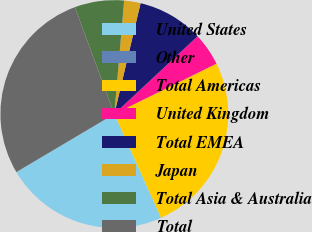Convert chart to OTSL. <chart><loc_0><loc_0><loc_500><loc_500><pie_chart><fcel>United States<fcel>Other<fcel>Total Americas<fcel>United Kingdom<fcel>Total EMEA<fcel>Japan<fcel>Total Asia & Australia<fcel>Total<nl><fcel>23.22%<fcel>0.0%<fcel>25.55%<fcel>4.67%<fcel>9.34%<fcel>2.33%<fcel>7.0%<fcel>27.89%<nl></chart> 